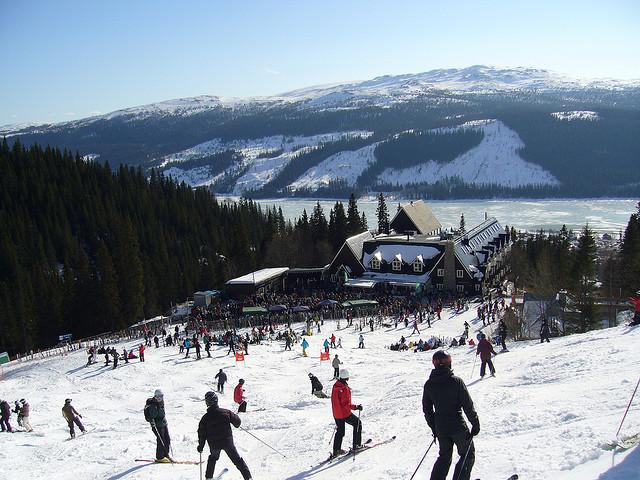Why is this area so crowded?
Give a very brief answer. Ski lodge. What sport are these people partaking in?
Be succinct. Skiing. What are these people doing?
Give a very brief answer. Skiing. How many people are wearing hats?
Short answer required. 7. Will children be skiing?
Write a very short answer. Yes. 